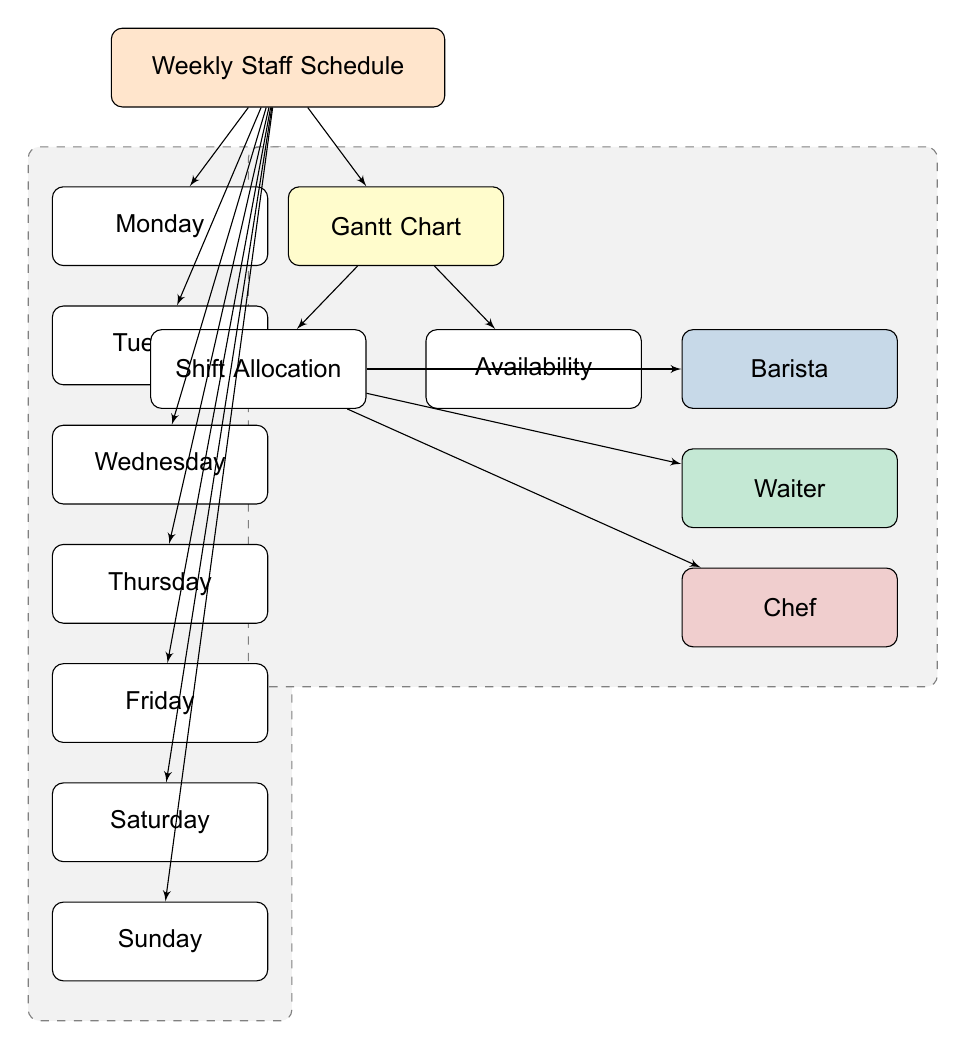What is the title of the diagram? The diagram title is indicated at the top and is labeled as "Weekly Staff Schedule."
Answer: Weekly Staff Schedule How many days of the week are listed in the diagram? The diagram lists seven days, from Monday to Sunday.
Answer: Seven Which job role is represented in blue? In the Gantt chart section, the job role color-coded in blue is shown as "Barista."
Answer: Barista What is the relationship between the Gantt Chart and Shift Allocation? The line connecting the Gantt Chart and Shift Allocation indicates that there is a direct relationship where the Gantt Chart presents the allocation of shifts.
Answer: Direct relationship How many job roles are included in the diagram? There are three job roles displayed: Barista, Waiter, and Chef.
Answer: Three What color is used to represent the Chef job role? The Chef job role is color-coded in red as indicated in the diagram.
Answer: Red Which day comes after Thursday in the diagram? The diagram shows the sequence of days, with Friday following Thursday in a vertical list.
Answer: Friday Which node connects to both Shift Allocation and Availability? The Gantt Chart node connects to both Shift Allocation and Availability, as indicated by the lines coming from it.
Answer: Gantt Chart What visual element distinguishes the job roles within the Gantt Chart? The job roles are visually distinguished by their unique color coding, with each role having a different background color.
Answer: Color coding 